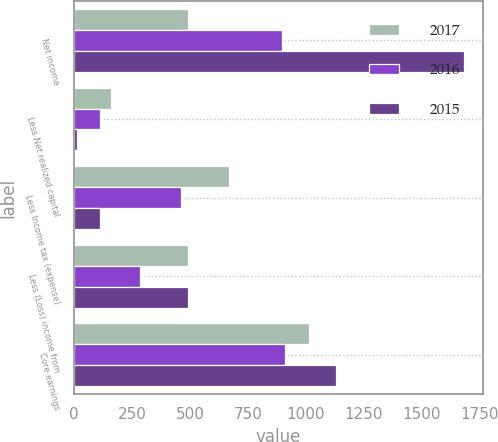<chart> <loc_0><loc_0><loc_500><loc_500><stacked_bar_chart><ecel><fcel>Net income<fcel>Less Net realized capital<fcel>Less Income tax (expense)<fcel>Less (Loss) income from<fcel>Core earnings<nl><fcel>2017<fcel>493<fcel>160<fcel>669<fcel>493<fcel>1014<nl><fcel>2016<fcel>896<fcel>112<fcel>463<fcel>283<fcel>912<nl><fcel>2015<fcel>1682<fcel>15<fcel>114<fcel>493<fcel>1131<nl></chart> 